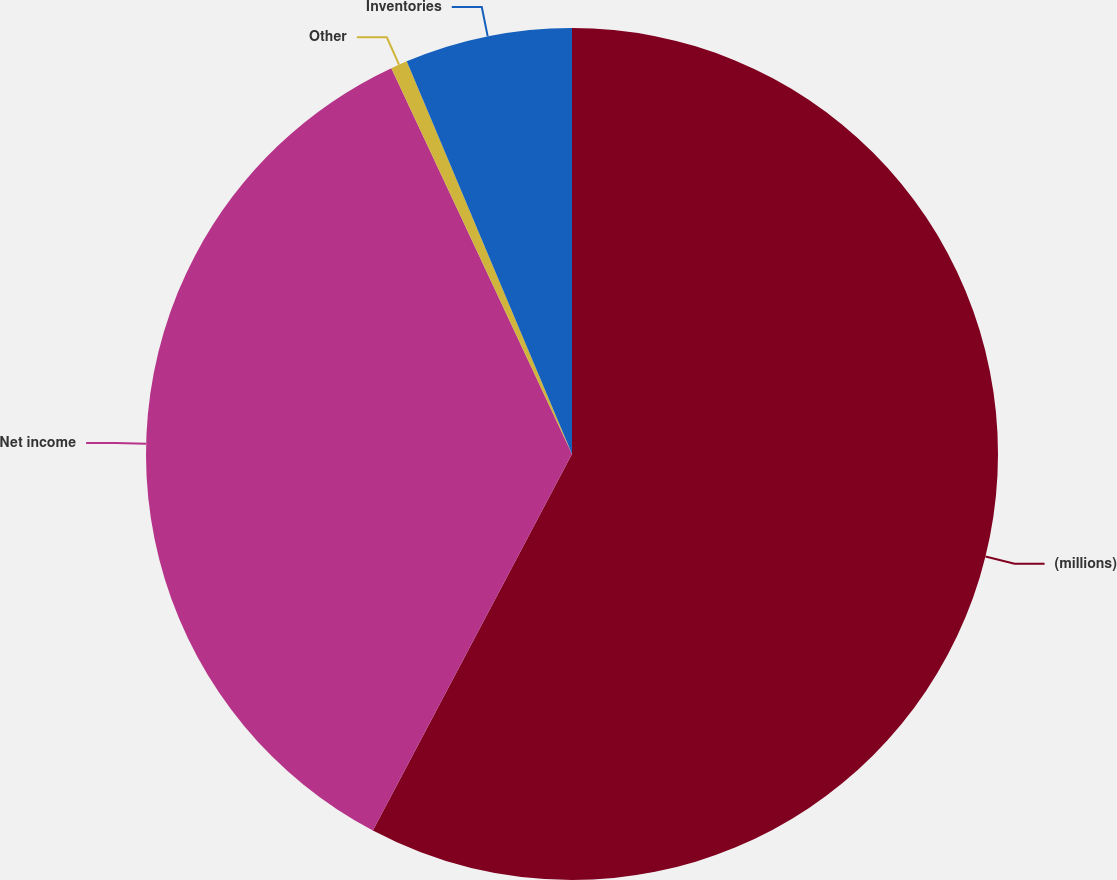Convert chart. <chart><loc_0><loc_0><loc_500><loc_500><pie_chart><fcel>(millions)<fcel>Net income<fcel>Other<fcel>Inventories<nl><fcel>57.74%<fcel>35.29%<fcel>0.63%<fcel>6.34%<nl></chart> 